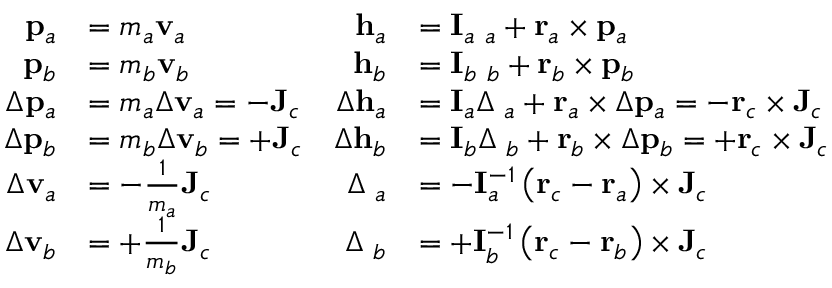Convert formula to latex. <formula><loc_0><loc_0><loc_500><loc_500>\begin{array} { r l r l } { { p } _ { a } } & { = m _ { a } { v } _ { a } } & { { h } _ { a } } & { = { I } _ { a } { \omega } _ { a } + { r } _ { a } \times { p } _ { a } } \\ { { p } _ { b } } & { = m _ { b } { v } _ { b } } & { { h } _ { b } } & { = { I } _ { b } { \omega } _ { b } + { r } _ { b } \times { p } _ { b } } \\ { \Delta { p } _ { a } } & { = m _ { a } \Delta { v } _ { a } = - { J } _ { c } } & { \Delta { h } _ { a } } & { = { I } _ { a } \Delta { \omega } _ { a } + { r } _ { a } \times \Delta { p } _ { a } = - { r } _ { c } \times { J } _ { c } } \\ { \Delta { p } _ { b } } & { = m _ { b } \Delta { v } _ { b } = + { J } _ { c } } & { \Delta { h } _ { b } } & { = { I } _ { b } \Delta { \omega } _ { b } + { r } _ { b } \times \Delta { p } _ { b } = + { r } _ { c } \times { J } _ { c } } \\ { \Delta { v } _ { a } } & { = - \frac { 1 } { m _ { a } } { J } _ { c } } & { \Delta { \omega } _ { a } } & { = - { I } _ { a } ^ { - 1 } \left ( { r } _ { c } - { r } _ { a } \right ) \times { J } _ { c } } \\ { \Delta { v } _ { b } } & { = + \frac { 1 } { m _ { b } } { J } _ { c } } & { \Delta { \omega } _ { b } } & { = + { I } _ { b } ^ { - 1 } \left ( { r } _ { c } - { r } _ { b } \right ) \times { J } _ { c } } \end{array}</formula> 